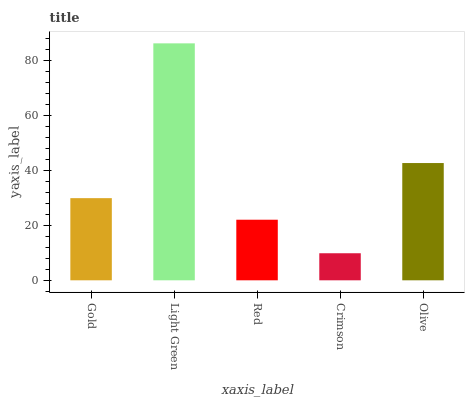Is Crimson the minimum?
Answer yes or no. Yes. Is Light Green the maximum?
Answer yes or no. Yes. Is Red the minimum?
Answer yes or no. No. Is Red the maximum?
Answer yes or no. No. Is Light Green greater than Red?
Answer yes or no. Yes. Is Red less than Light Green?
Answer yes or no. Yes. Is Red greater than Light Green?
Answer yes or no. No. Is Light Green less than Red?
Answer yes or no. No. Is Gold the high median?
Answer yes or no. Yes. Is Gold the low median?
Answer yes or no. Yes. Is Crimson the high median?
Answer yes or no. No. Is Crimson the low median?
Answer yes or no. No. 